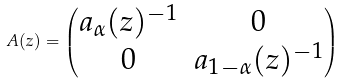Convert formula to latex. <formula><loc_0><loc_0><loc_500><loc_500>A ( z ) = \begin{pmatrix} a _ { \alpha } ( z ) ^ { - 1 } & 0 \\ 0 & a _ { 1 - \alpha } ( z ) ^ { - 1 } \end{pmatrix}</formula> 